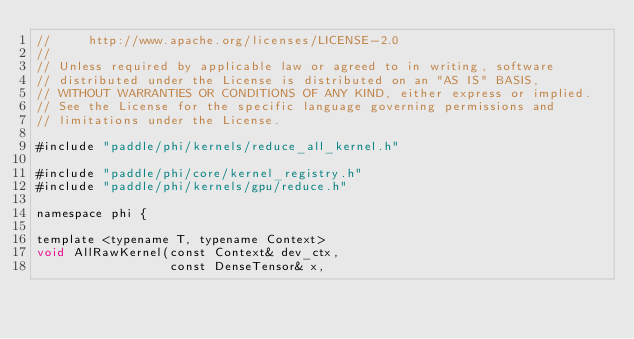<code> <loc_0><loc_0><loc_500><loc_500><_Cuda_>//     http://www.apache.org/licenses/LICENSE-2.0
//
// Unless required by applicable law or agreed to in writing, software
// distributed under the License is distributed on an "AS IS" BASIS,
// WITHOUT WARRANTIES OR CONDITIONS OF ANY KIND, either express or implied.
// See the License for the specific language governing permissions and
// limitations under the License.

#include "paddle/phi/kernels/reduce_all_kernel.h"

#include "paddle/phi/core/kernel_registry.h"
#include "paddle/phi/kernels/gpu/reduce.h"

namespace phi {

template <typename T, typename Context>
void AllRawKernel(const Context& dev_ctx,
                  const DenseTensor& x,</code> 